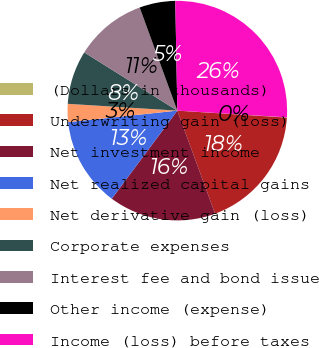<chart> <loc_0><loc_0><loc_500><loc_500><pie_chart><fcel>(Dollars in thousands)<fcel>Underwriting gain (loss)<fcel>Net investment income<fcel>Net realized capital gains<fcel>Net derivative gain (loss)<fcel>Corporate expenses<fcel>Interest fee and bond issue<fcel>Other income (expense)<fcel>Income (loss) before taxes<nl><fcel>0.04%<fcel>18.4%<fcel>15.77%<fcel>13.15%<fcel>2.66%<fcel>7.91%<fcel>10.53%<fcel>5.28%<fcel>26.27%<nl></chart> 